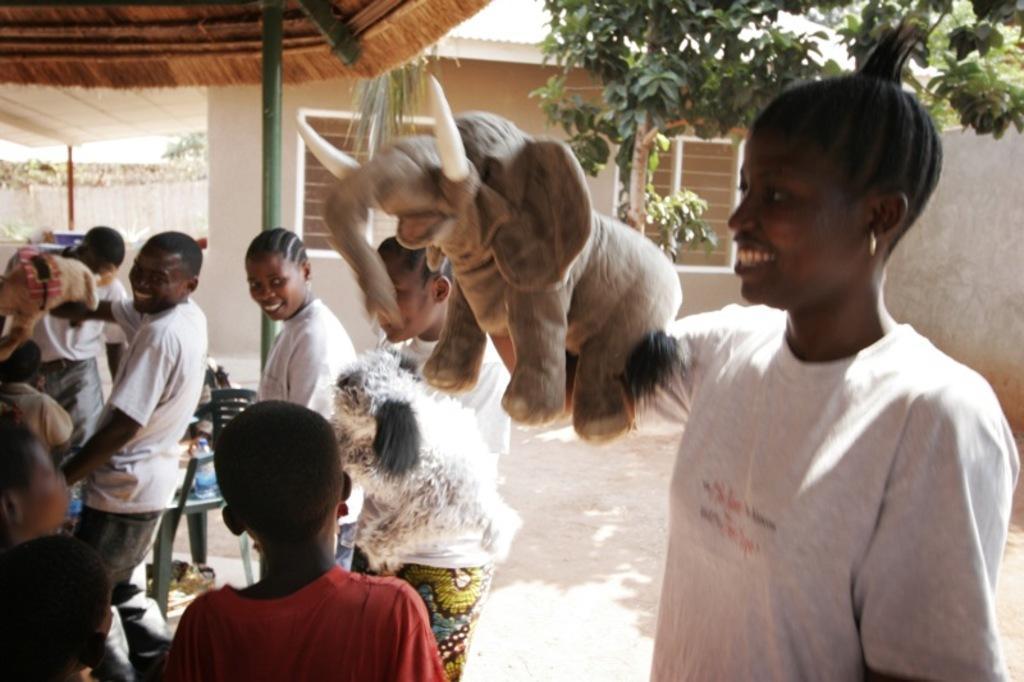Could you give a brief overview of what you see in this image? In this picture we can see a group of people, toys, chair, shelter and some objects. In the background we can see the walls, trees and a house with windows. 